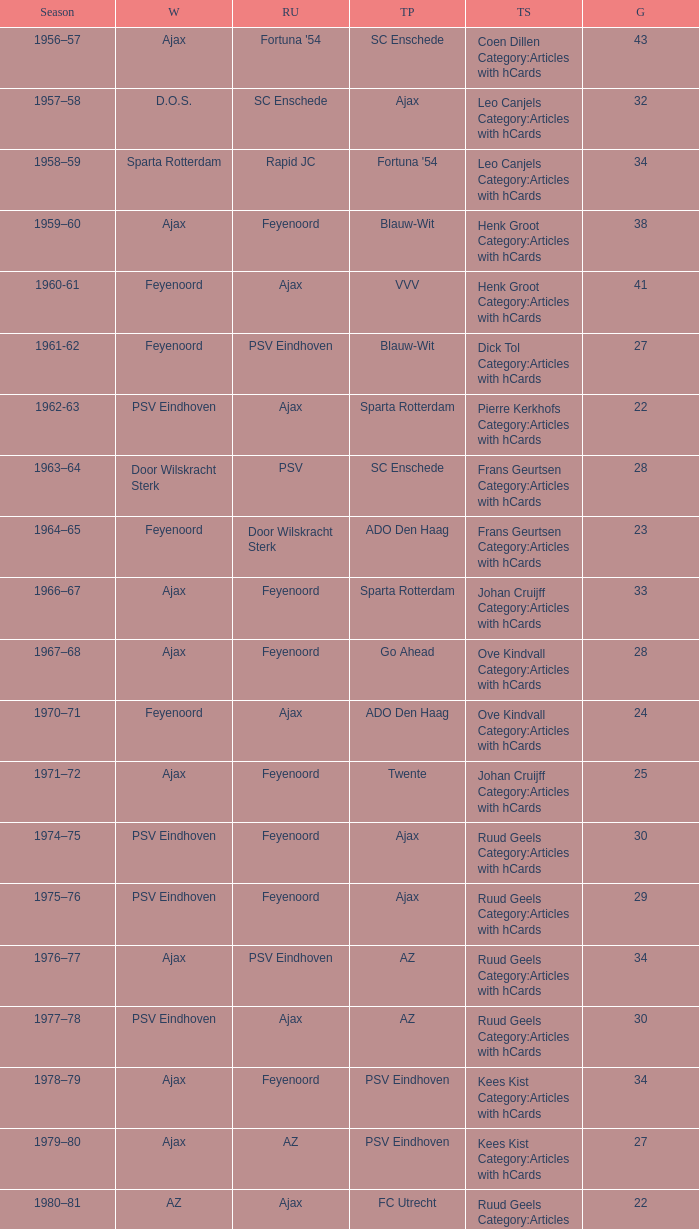When az is the runner up nad feyenoord came in third place how many overall winners are there? 1.0. Write the full table. {'header': ['Season', 'W', 'RU', 'TP', 'TS', 'G'], 'rows': [['1956–57', 'Ajax', "Fortuna '54", 'SC Enschede', 'Coen Dillen Category:Articles with hCards', '43'], ['1957–58', 'D.O.S.', 'SC Enschede', 'Ajax', 'Leo Canjels Category:Articles with hCards', '32'], ['1958–59', 'Sparta Rotterdam', 'Rapid JC', "Fortuna '54", 'Leo Canjels Category:Articles with hCards', '34'], ['1959–60', 'Ajax', 'Feyenoord', 'Blauw-Wit', 'Henk Groot Category:Articles with hCards', '38'], ['1960-61', 'Feyenoord', 'Ajax', 'VVV', 'Henk Groot Category:Articles with hCards', '41'], ['1961-62', 'Feyenoord', 'PSV Eindhoven', 'Blauw-Wit', 'Dick Tol Category:Articles with hCards', '27'], ['1962-63', 'PSV Eindhoven', 'Ajax', 'Sparta Rotterdam', 'Pierre Kerkhofs Category:Articles with hCards', '22'], ['1963–64', 'Door Wilskracht Sterk', 'PSV', 'SC Enschede', 'Frans Geurtsen Category:Articles with hCards', '28'], ['1964–65', 'Feyenoord', 'Door Wilskracht Sterk', 'ADO Den Haag', 'Frans Geurtsen Category:Articles with hCards', '23'], ['1966–67', 'Ajax', 'Feyenoord', 'Sparta Rotterdam', 'Johan Cruijff Category:Articles with hCards', '33'], ['1967–68', 'Ajax', 'Feyenoord', 'Go Ahead', 'Ove Kindvall Category:Articles with hCards', '28'], ['1970–71', 'Feyenoord', 'Ajax', 'ADO Den Haag', 'Ove Kindvall Category:Articles with hCards', '24'], ['1971–72', 'Ajax', 'Feyenoord', 'Twente', 'Johan Cruijff Category:Articles with hCards', '25'], ['1974–75', 'PSV Eindhoven', 'Feyenoord', 'Ajax', 'Ruud Geels Category:Articles with hCards', '30'], ['1975–76', 'PSV Eindhoven', 'Feyenoord', 'Ajax', 'Ruud Geels Category:Articles with hCards', '29'], ['1976–77', 'Ajax', 'PSV Eindhoven', 'AZ', 'Ruud Geels Category:Articles with hCards', '34'], ['1977–78', 'PSV Eindhoven', 'Ajax', 'AZ', 'Ruud Geels Category:Articles with hCards', '30'], ['1978–79', 'Ajax', 'Feyenoord', 'PSV Eindhoven', 'Kees Kist Category:Articles with hCards', '34'], ['1979–80', 'Ajax', 'AZ', 'PSV Eindhoven', 'Kees Kist Category:Articles with hCards', '27'], ['1980–81', 'AZ', 'Ajax', 'FC Utrecht', 'Ruud Geels Category:Articles with hCards', '22'], ['1981-82', 'Ajax', 'PSV Eindhoven', 'AZ', 'Wim Kieft Category:Articles with hCards', '32'], ['1982-83', 'Ajax', 'Feyenoord', 'PSV Eindhoven', 'Peter Houtman Category:Articles with hCards', '30'], ['1983-84', 'Feyenoord', 'PSV Eindhoven', 'Ajax', 'Marco van Basten Category:Articles with hCards', '28'], ['1984-85', 'Ajax', 'PSV Eindhoven', 'Feyenoord', 'Marco van Basten Category:Articles with hCards', '22'], ['1985-86', 'PSV Eindhoven', 'Ajax', 'Feyenoord', 'Marco van Basten Category:Articles with hCards', '37'], ['1986-87', 'PSV Eindhoven', 'Ajax', 'Feyenoord', 'Marco van Basten Category:Articles with hCards', '31'], ['1987-88', 'PSV Eindhoven', 'Ajax', 'Twente', 'Wim Kieft Category:Articles with hCards', '29'], ['1988–89', 'PSV Eindhoven', 'Ajax', 'Twente', 'Romário', '19'], ['1989-90', 'Ajax', 'PSV Eindhoven', 'Twente', 'Romário', '23'], ['1990–91', 'PSV Eindhoven', 'Ajax', 'FC Groningen', 'Romário Dennis Bergkamp', '25'], ['1991–92', 'PSV Eindhoven', 'Ajax', 'Feyenoord', 'Dennis Bergkamp Category:Articles with hCards', '22'], ['1992–93', 'Feyenoord', 'PSV Eindhoven', 'Ajax', 'Dennis Bergkamp Category:Articles with hCards', '26'], ['1993–94', 'Ajax', 'Feyenoord', 'PSV Eindhoven', 'Jari Litmanen Category:Articles with hCards', '26'], ['1994–95', 'Ajax', 'Roda JC', 'PSV Eindhoven', 'Ronaldo', '30'], ['1995–96', 'Ajax', 'PSV Eindhoven', 'Feyenoord', 'Luc Nilis Category:Articles with hCards', '21'], ['1996–97', 'PSV Eindhoven', 'Feyenoord', 'Twente', 'Luc Nilis Category:Articles with hCards', '21'], ['1997–98', 'Ajax', 'PSV Eindhoven', 'Vitesse', 'Nikos Machlas Category:Articles with hCards', '34'], ['1998–99', 'Feyenoord', 'Willem II', 'PSV Eindhoven', 'Ruud van Nistelrooy Category:Articles with hCards', '31'], ['1999–2000', 'PSV Eindhoven', 'Heerenveen', 'Feyenoord', 'Ruud van Nistelrooy Category:Articles with hCards', '29'], ['2000–01', 'PSV Eindhoven', 'Feyenoord', 'Ajax', 'Mateja Kežman Category:Articles with hCards', '24'], ['2001–02', 'Ajax', 'PSV Eindhoven', 'Feyenoord', 'Pierre van Hooijdonk Category:Articles with hCards', '24'], ['2002-03', 'PSV Eindhoven', 'Ajax', 'Feyenoord', 'Mateja Kežman Category:Articles with hCards', '35'], ['2003-04', 'Ajax', 'PSV Eindhoven', 'Feyenoord', 'Mateja Kežman Category:Articles with hCards', '31'], ['2004-05', 'PSV Eindhoven', 'Ajax', 'AZ', 'Dirk Kuyt Category:Articles with hCards', '29'], ['2005-06', 'PSV Eindhoven', 'AZ', 'Feyenoord', 'Klaas-Jan Huntelaar Category:Articles with hCards', '33'], ['2006-07', 'PSV Eindhoven', 'Ajax', 'AZ', 'Afonso Alves Category:Articles with hCards', '34'], ['2007-08', 'PSV Eindhoven', 'Ajax', 'NAC Breda', 'Klaas-Jan Huntelaar Category:Articles with hCards', '33'], ['2008-09', 'AZ', 'Twente', 'Ajax', 'Mounir El Hamdaoui Category:Articles with hCards', '23'], ['2009-10', 'Twente', 'Ajax', 'PSV Eindhoven', 'Luis Suárez Category:Articles with hCards', '35'], ['2010-11', 'Ajax', 'Twente', 'PSV Eindhoven', 'Björn Vleminckx Category:Articles with hCards', '23'], ['2011-12', 'Ajax', 'Feyenoord', 'PSV Eindhoven', 'Bas Dost Category:Articles with hCards', '32']]} 